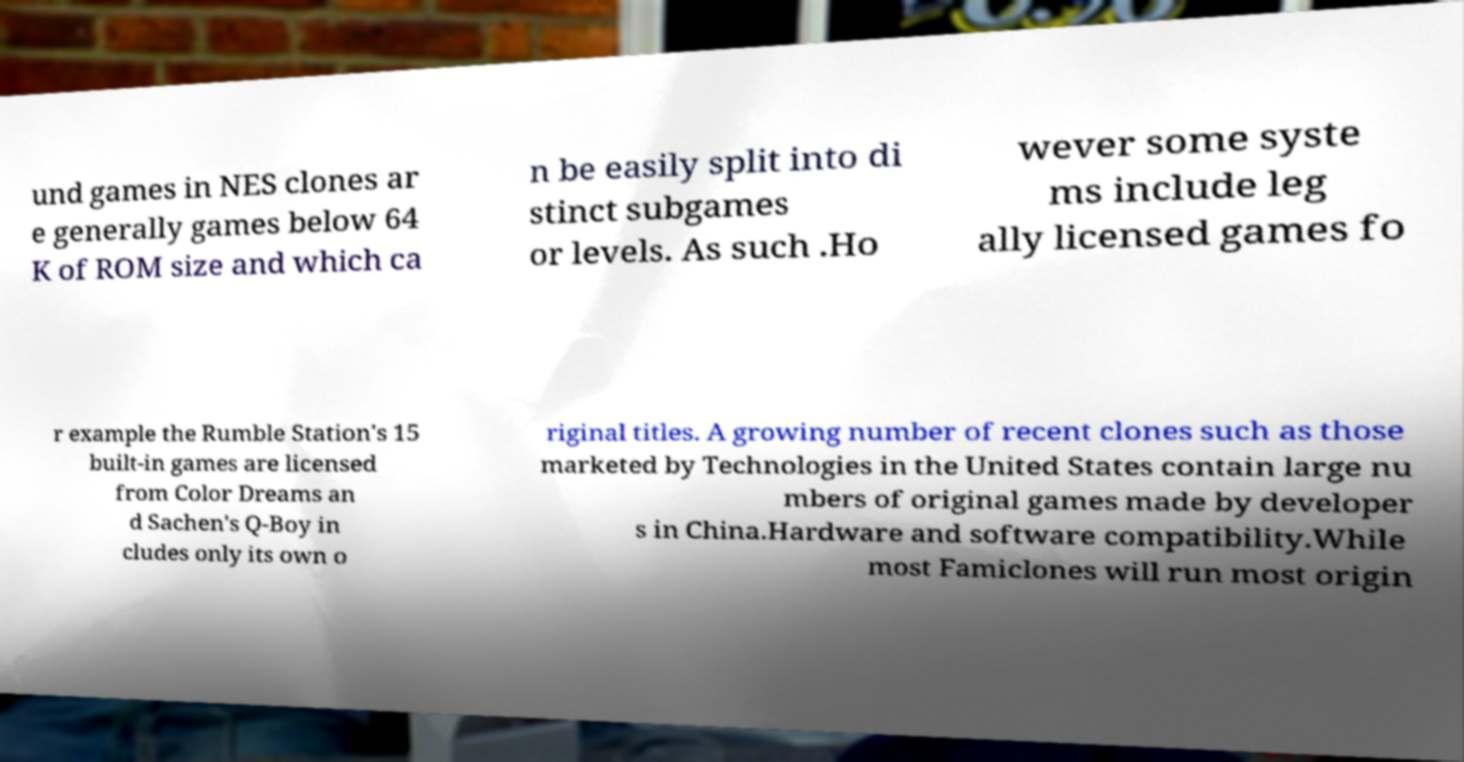Can you accurately transcribe the text from the provided image for me? und games in NES clones ar e generally games below 64 K of ROM size and which ca n be easily split into di stinct subgames or levels. As such .Ho wever some syste ms include leg ally licensed games fo r example the Rumble Station's 15 built-in games are licensed from Color Dreams an d Sachen's Q-Boy in cludes only its own o riginal titles. A growing number of recent clones such as those marketed by Technologies in the United States contain large nu mbers of original games made by developer s in China.Hardware and software compatibility.While most Famiclones will run most origin 